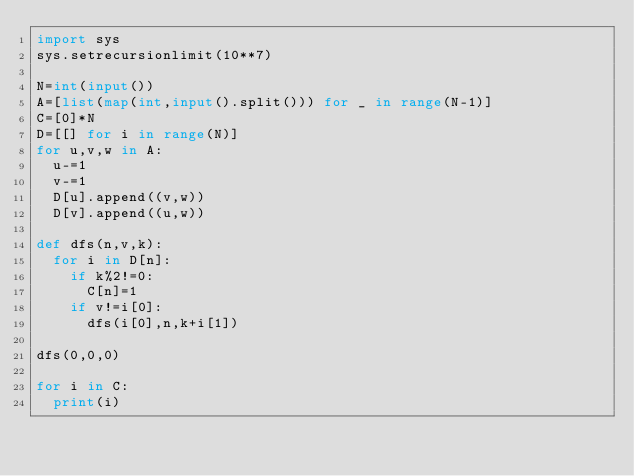<code> <loc_0><loc_0><loc_500><loc_500><_Python_>import sys
sys.setrecursionlimit(10**7)

N=int(input())
A=[list(map(int,input().split())) for _ in range(N-1)]
C=[0]*N
D=[[] for i in range(N)]
for u,v,w in A:
  u-=1
  v-=1
  D[u].append((v,w))
  D[v].append((u,w))

def dfs(n,v,k):
  for i in D[n]:
    if k%2!=0:
      C[n]=1
    if v!=i[0]:
      dfs(i[0],n,k+i[1])       
        
dfs(0,0,0)

for i in C:
  print(i)</code> 